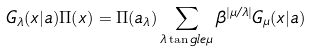<formula> <loc_0><loc_0><loc_500><loc_500>G _ { \lambda } ( x | a ) \Pi ( x ) = \Pi ( a _ { \lambda } ) \sum _ { \lambda \tan g l e \mu } \beta ^ { | \mu / \lambda | } G _ { \mu } ( x | a )</formula> 